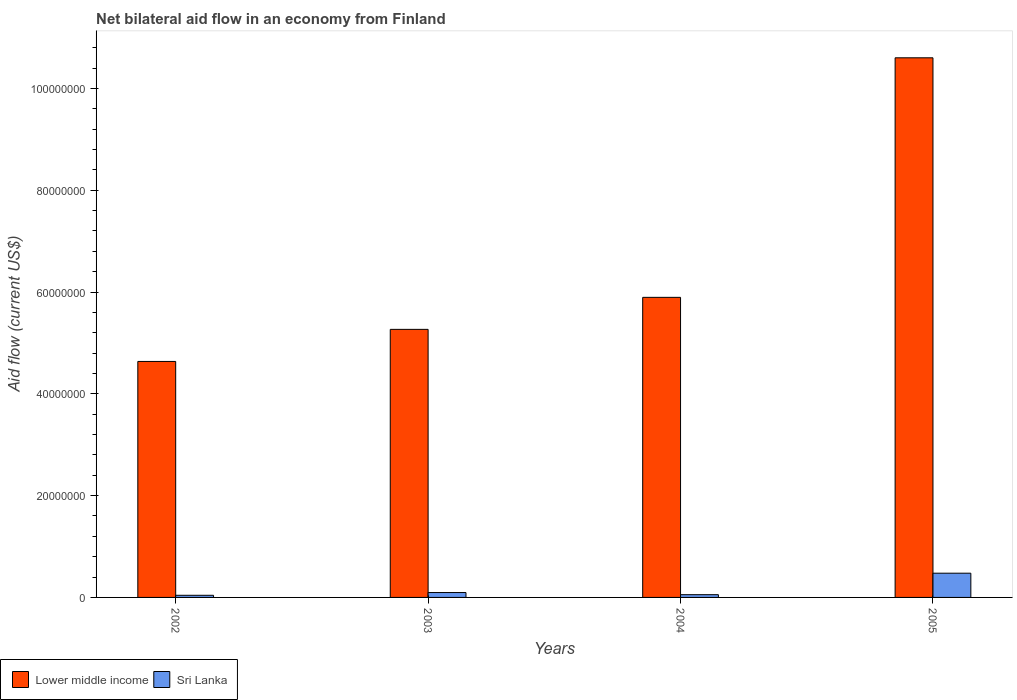How many different coloured bars are there?
Your answer should be compact. 2. What is the label of the 2nd group of bars from the left?
Ensure brevity in your answer.  2003. In how many cases, is the number of bars for a given year not equal to the number of legend labels?
Provide a short and direct response. 0. What is the net bilateral aid flow in Lower middle income in 2002?
Keep it short and to the point. 4.64e+07. Across all years, what is the maximum net bilateral aid flow in Lower middle income?
Offer a very short reply. 1.06e+08. Across all years, what is the minimum net bilateral aid flow in Sri Lanka?
Offer a very short reply. 4.20e+05. In which year was the net bilateral aid flow in Sri Lanka maximum?
Ensure brevity in your answer.  2005. In which year was the net bilateral aid flow in Sri Lanka minimum?
Provide a short and direct response. 2002. What is the total net bilateral aid flow in Sri Lanka in the graph?
Provide a short and direct response. 6.68e+06. What is the difference between the net bilateral aid flow in Sri Lanka in 2003 and that in 2004?
Provide a succinct answer. 4.20e+05. What is the difference between the net bilateral aid flow in Lower middle income in 2002 and the net bilateral aid flow in Sri Lanka in 2004?
Provide a short and direct response. 4.58e+07. What is the average net bilateral aid flow in Lower middle income per year?
Your response must be concise. 6.60e+07. In the year 2004, what is the difference between the net bilateral aid flow in Sri Lanka and net bilateral aid flow in Lower middle income?
Your answer should be compact. -5.84e+07. In how many years, is the net bilateral aid flow in Lower middle income greater than 96000000 US$?
Make the answer very short. 1. What is the ratio of the net bilateral aid flow in Sri Lanka in 2002 to that in 2004?
Your answer should be compact. 0.78. What is the difference between the highest and the second highest net bilateral aid flow in Lower middle income?
Offer a terse response. 4.71e+07. What is the difference between the highest and the lowest net bilateral aid flow in Lower middle income?
Your answer should be compact. 5.96e+07. Is the sum of the net bilateral aid flow in Lower middle income in 2003 and 2005 greater than the maximum net bilateral aid flow in Sri Lanka across all years?
Your answer should be compact. Yes. What does the 2nd bar from the left in 2005 represents?
Your response must be concise. Sri Lanka. What does the 1st bar from the right in 2003 represents?
Keep it short and to the point. Sri Lanka. Are all the bars in the graph horizontal?
Offer a terse response. No. How many years are there in the graph?
Ensure brevity in your answer.  4. What is the difference between two consecutive major ticks on the Y-axis?
Your answer should be compact. 2.00e+07. Are the values on the major ticks of Y-axis written in scientific E-notation?
Provide a short and direct response. No. How many legend labels are there?
Keep it short and to the point. 2. What is the title of the graph?
Offer a terse response. Net bilateral aid flow in an economy from Finland. Does "Morocco" appear as one of the legend labels in the graph?
Give a very brief answer. No. What is the label or title of the Y-axis?
Give a very brief answer. Aid flow (current US$). What is the Aid flow (current US$) in Lower middle income in 2002?
Keep it short and to the point. 4.64e+07. What is the Aid flow (current US$) of Sri Lanka in 2002?
Provide a succinct answer. 4.20e+05. What is the Aid flow (current US$) of Lower middle income in 2003?
Keep it short and to the point. 5.27e+07. What is the Aid flow (current US$) of Sri Lanka in 2003?
Offer a terse response. 9.60e+05. What is the Aid flow (current US$) of Lower middle income in 2004?
Offer a terse response. 5.90e+07. What is the Aid flow (current US$) in Sri Lanka in 2004?
Offer a terse response. 5.40e+05. What is the Aid flow (current US$) in Lower middle income in 2005?
Make the answer very short. 1.06e+08. What is the Aid flow (current US$) in Sri Lanka in 2005?
Your response must be concise. 4.76e+06. Across all years, what is the maximum Aid flow (current US$) of Lower middle income?
Provide a succinct answer. 1.06e+08. Across all years, what is the maximum Aid flow (current US$) in Sri Lanka?
Offer a terse response. 4.76e+06. Across all years, what is the minimum Aid flow (current US$) of Lower middle income?
Your response must be concise. 4.64e+07. What is the total Aid flow (current US$) in Lower middle income in the graph?
Give a very brief answer. 2.64e+08. What is the total Aid flow (current US$) of Sri Lanka in the graph?
Give a very brief answer. 6.68e+06. What is the difference between the Aid flow (current US$) of Lower middle income in 2002 and that in 2003?
Make the answer very short. -6.30e+06. What is the difference between the Aid flow (current US$) of Sri Lanka in 2002 and that in 2003?
Offer a very short reply. -5.40e+05. What is the difference between the Aid flow (current US$) of Lower middle income in 2002 and that in 2004?
Give a very brief answer. -1.26e+07. What is the difference between the Aid flow (current US$) of Lower middle income in 2002 and that in 2005?
Ensure brevity in your answer.  -5.96e+07. What is the difference between the Aid flow (current US$) of Sri Lanka in 2002 and that in 2005?
Your answer should be compact. -4.34e+06. What is the difference between the Aid flow (current US$) of Lower middle income in 2003 and that in 2004?
Offer a terse response. -6.29e+06. What is the difference between the Aid flow (current US$) of Lower middle income in 2003 and that in 2005?
Keep it short and to the point. -5.34e+07. What is the difference between the Aid flow (current US$) in Sri Lanka in 2003 and that in 2005?
Ensure brevity in your answer.  -3.80e+06. What is the difference between the Aid flow (current US$) of Lower middle income in 2004 and that in 2005?
Offer a very short reply. -4.71e+07. What is the difference between the Aid flow (current US$) of Sri Lanka in 2004 and that in 2005?
Offer a very short reply. -4.22e+06. What is the difference between the Aid flow (current US$) of Lower middle income in 2002 and the Aid flow (current US$) of Sri Lanka in 2003?
Your answer should be compact. 4.54e+07. What is the difference between the Aid flow (current US$) in Lower middle income in 2002 and the Aid flow (current US$) in Sri Lanka in 2004?
Your answer should be compact. 4.58e+07. What is the difference between the Aid flow (current US$) of Lower middle income in 2002 and the Aid flow (current US$) of Sri Lanka in 2005?
Your answer should be compact. 4.16e+07. What is the difference between the Aid flow (current US$) of Lower middle income in 2003 and the Aid flow (current US$) of Sri Lanka in 2004?
Offer a very short reply. 5.21e+07. What is the difference between the Aid flow (current US$) of Lower middle income in 2003 and the Aid flow (current US$) of Sri Lanka in 2005?
Provide a succinct answer. 4.79e+07. What is the difference between the Aid flow (current US$) of Lower middle income in 2004 and the Aid flow (current US$) of Sri Lanka in 2005?
Make the answer very short. 5.42e+07. What is the average Aid flow (current US$) in Lower middle income per year?
Offer a very short reply. 6.60e+07. What is the average Aid flow (current US$) in Sri Lanka per year?
Give a very brief answer. 1.67e+06. In the year 2002, what is the difference between the Aid flow (current US$) of Lower middle income and Aid flow (current US$) of Sri Lanka?
Keep it short and to the point. 4.59e+07. In the year 2003, what is the difference between the Aid flow (current US$) of Lower middle income and Aid flow (current US$) of Sri Lanka?
Make the answer very short. 5.17e+07. In the year 2004, what is the difference between the Aid flow (current US$) in Lower middle income and Aid flow (current US$) in Sri Lanka?
Ensure brevity in your answer.  5.84e+07. In the year 2005, what is the difference between the Aid flow (current US$) of Lower middle income and Aid flow (current US$) of Sri Lanka?
Offer a very short reply. 1.01e+08. What is the ratio of the Aid flow (current US$) of Lower middle income in 2002 to that in 2003?
Offer a terse response. 0.88. What is the ratio of the Aid flow (current US$) in Sri Lanka in 2002 to that in 2003?
Your response must be concise. 0.44. What is the ratio of the Aid flow (current US$) of Lower middle income in 2002 to that in 2004?
Give a very brief answer. 0.79. What is the ratio of the Aid flow (current US$) in Sri Lanka in 2002 to that in 2004?
Your response must be concise. 0.78. What is the ratio of the Aid flow (current US$) of Lower middle income in 2002 to that in 2005?
Provide a succinct answer. 0.44. What is the ratio of the Aid flow (current US$) in Sri Lanka in 2002 to that in 2005?
Your response must be concise. 0.09. What is the ratio of the Aid flow (current US$) in Lower middle income in 2003 to that in 2004?
Provide a short and direct response. 0.89. What is the ratio of the Aid flow (current US$) of Sri Lanka in 2003 to that in 2004?
Provide a short and direct response. 1.78. What is the ratio of the Aid flow (current US$) of Lower middle income in 2003 to that in 2005?
Give a very brief answer. 0.5. What is the ratio of the Aid flow (current US$) of Sri Lanka in 2003 to that in 2005?
Give a very brief answer. 0.2. What is the ratio of the Aid flow (current US$) of Lower middle income in 2004 to that in 2005?
Your answer should be compact. 0.56. What is the ratio of the Aid flow (current US$) in Sri Lanka in 2004 to that in 2005?
Offer a very short reply. 0.11. What is the difference between the highest and the second highest Aid flow (current US$) in Lower middle income?
Give a very brief answer. 4.71e+07. What is the difference between the highest and the second highest Aid flow (current US$) of Sri Lanka?
Provide a succinct answer. 3.80e+06. What is the difference between the highest and the lowest Aid flow (current US$) in Lower middle income?
Your answer should be very brief. 5.96e+07. What is the difference between the highest and the lowest Aid flow (current US$) in Sri Lanka?
Provide a short and direct response. 4.34e+06. 